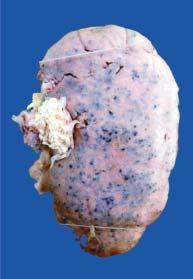what shows characteristic 'flea bitten kidney ' due to tiny petechial haemorrhages on the surface?
Answer the question using a single word or phrase. Cortex 